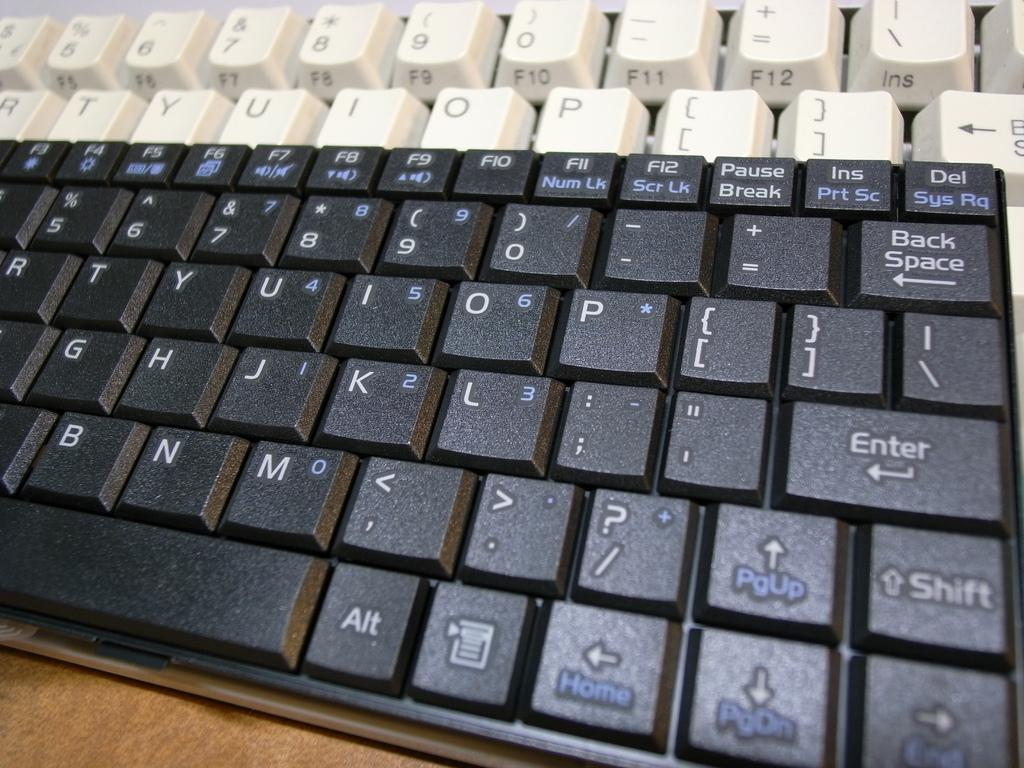<image>
Offer a succinct explanation of the picture presented. A close up of a keyboard in both white and black but the first letter shown in white is R. 